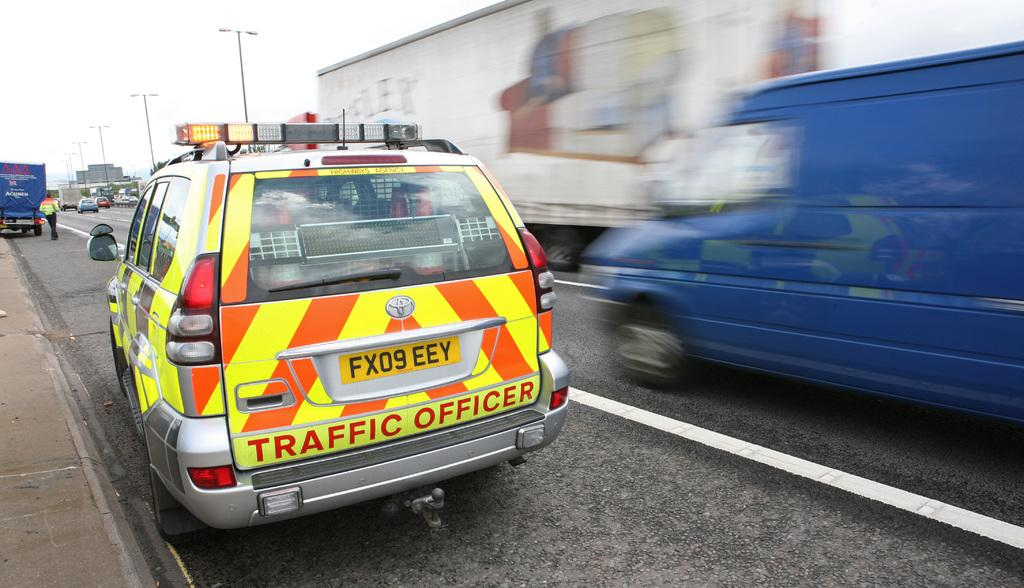<image>
Describe the image concisely. An orange and yellow striped vehicle with Traffic Officer written on the back. 